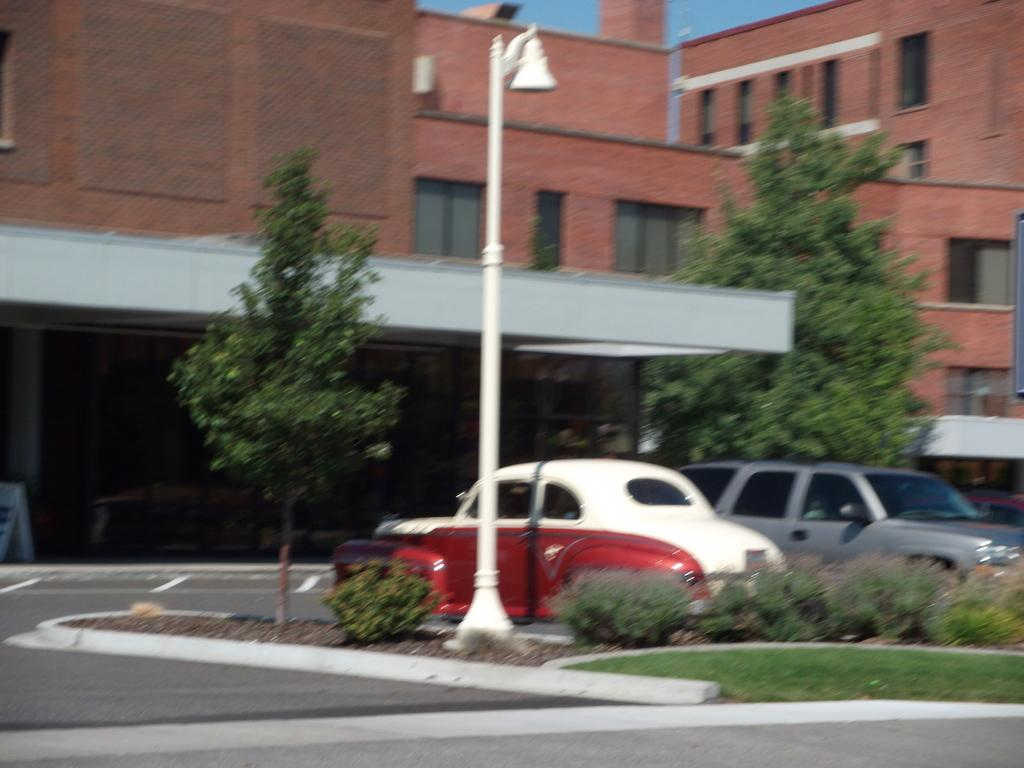What is the main feature of the image? There is a road in the image. What can be seen on the road? There are cars in the image. What type of structures are present in the image? There is a building and a wall in the background of the image. What natural elements are visible in the image? There are plants and trees in the image. What is visible in the sky? The sky is visible in the background of the image. How many yams are being held by the babies in the image? There are no babies or yams present in the image. What number is written on the wall in the image? There is no number visible on the wall in the image. 